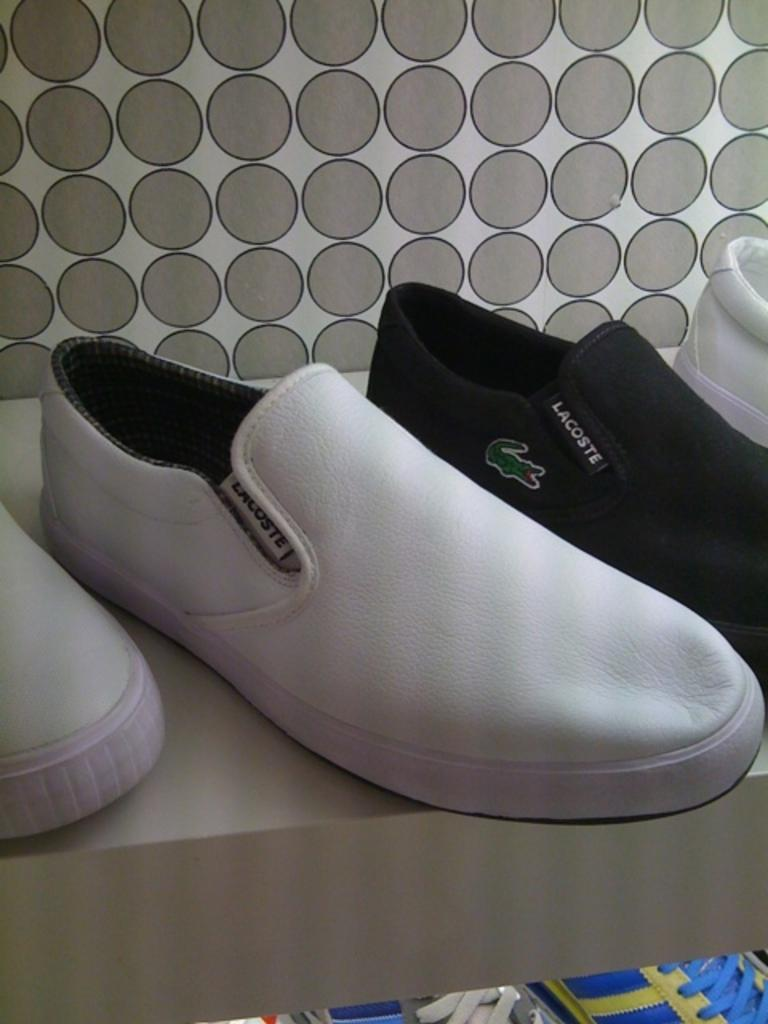What is the object that the shoes are placed on in the image? The object is not specified in the facts, but the shoes are on something in the image. What is located in front of the shoes? There is a box in front of the shoes. What is visible behind the shoes? There is a wall behind the shoes. Is there a plantation visible in the image? No, there is no mention of a plantation in the provided facts, and it is not visible in the image. What force is being applied to the shoes in the image? There is no indication of any force being applied to the shoes in the image. 